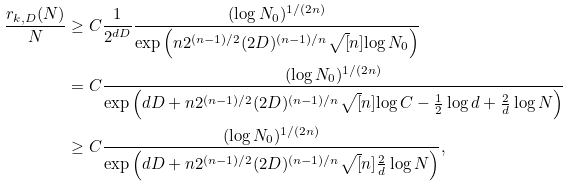Convert formula to latex. <formula><loc_0><loc_0><loc_500><loc_500>\frac { r _ { k , D } ( N ) } { N } & \geq C \frac { 1 } { 2 ^ { d D } } \frac { ( \log N _ { 0 } ) ^ { 1 / ( 2 n ) } } { \exp \left ( n 2 ^ { ( n - 1 ) / 2 } ( 2 D ) ^ { ( n - 1 ) / n } \sqrt { [ } n ] { \log N _ { 0 } } \right ) } \\ & = C \frac { ( \log N _ { 0 } ) ^ { 1 / ( 2 n ) } } { \exp \left ( d D + n 2 ^ { ( n - 1 ) / 2 } ( 2 D ) ^ { ( n - 1 ) / n } \sqrt { [ } n ] { \log C - \frac { 1 } { 2 } \log d + \frac { 2 } { d } \log N } \right ) } \\ & \geq C \frac { ( \log N _ { 0 } ) ^ { 1 / ( 2 n ) } } { \exp \left ( d D + n 2 ^ { ( n - 1 ) / 2 } ( 2 D ) ^ { ( n - 1 ) / n } \sqrt { [ } n ] { \frac { 2 } { d } \log N } \right ) } ,</formula> 